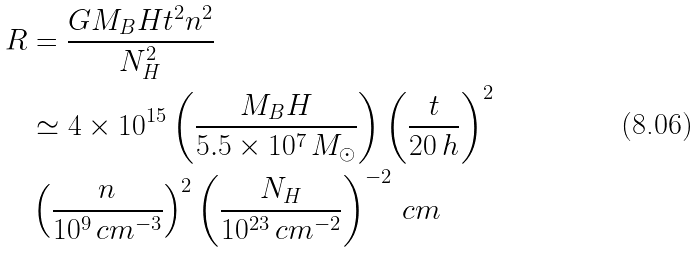Convert formula to latex. <formula><loc_0><loc_0><loc_500><loc_500>R & = \frac { G M _ { B } H t ^ { 2 } n ^ { 2 } } { N _ { H } ^ { 2 } } \\ & \simeq 4 \times 1 0 ^ { 1 5 } \left ( \frac { M _ { B } H } { 5 . 5 \times 1 0 ^ { 7 } \, M _ { \odot } } \right ) \left ( \frac { t } { 2 0 \, h } \right ) ^ { 2 } \\ & \left ( \frac { n } { 1 0 ^ { 9 } \, c m ^ { - 3 } } \right ) ^ { 2 } \left ( \frac { N _ { H } } { 1 0 ^ { 2 3 } \, c m ^ { - 2 } } \right ) ^ { - 2 } \, c m</formula> 